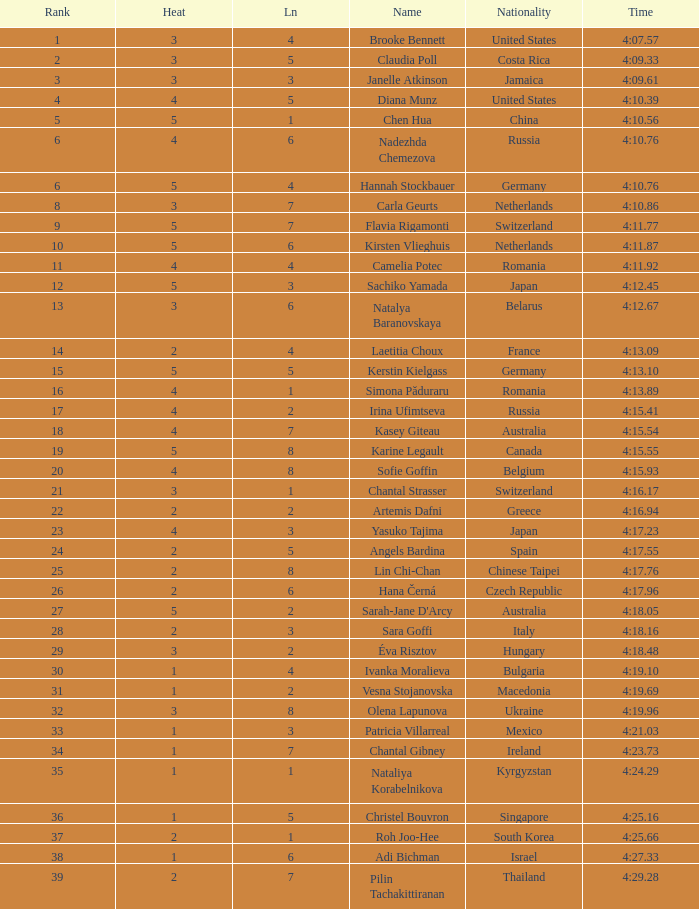Name the least lane for kasey giteau and rank less than 18 None. 